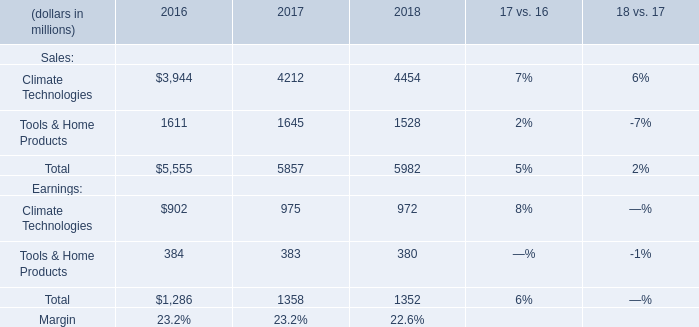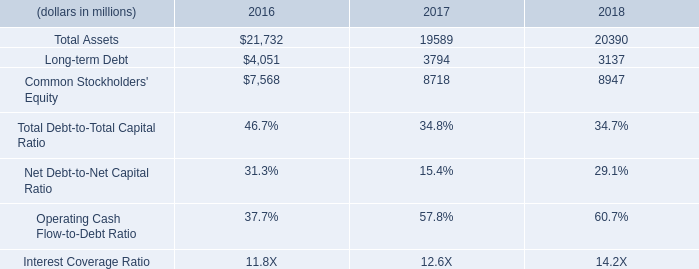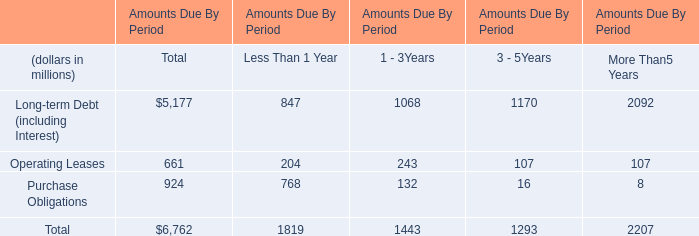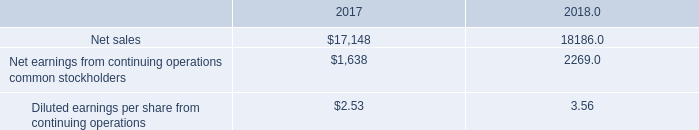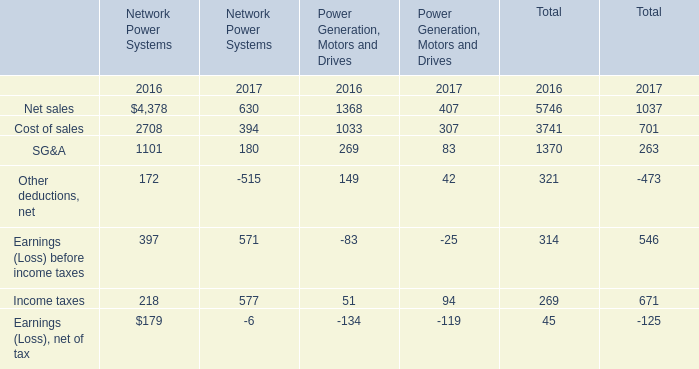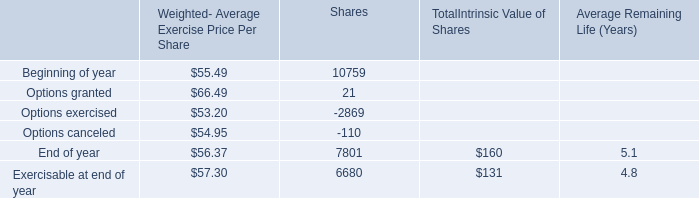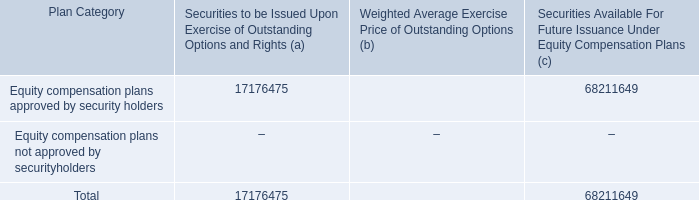What is the percentage of Net sales in relation to the total in 2017? 
Computations: (17148 / (17148 + 1638))
Answer: 0.91281. 